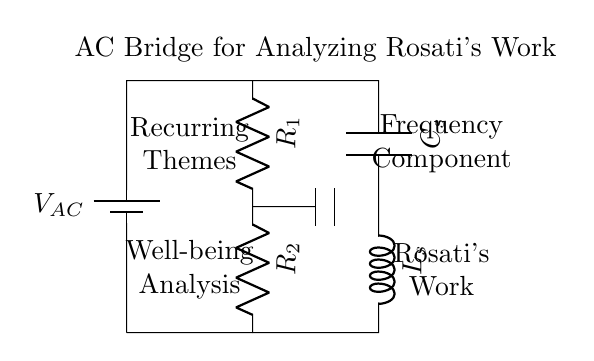What is the voltage source in this circuit? The voltage source is indicated by the battery symbol labeled with \( V_{AC} \) at the top left of the circuit diagram, suggesting it is an alternating current source.
Answer: V_{AC} How many resistors are present in the circuit? The diagram shows two resistors labeled \( R_1 \) and \( R_2 \). Both are connected in series in the left branch of the circuit.
Answer: 2 Which components are connected in parallel? The capacitor \( C_s \) and the inductor \( L_s \) are positioned in parallel within the right branch of the circuit, connecting at their respective terminals to the common nodes.
Answer: Capacitor and inductor What is the purpose of this AC bridge circuit? The AC bridge circuit is designed to analyze recurring themes in Rosati's work on well-being by measuring frequency components associated with the resonant characteristics of the network.
Answer: Analyze themes What happens to the voltage across the resistors when the circuit is balanced? When the AC bridge is balanced, the voltage across the resistors \( R_1 \) and \( R_2 \) will be equal, resulting in no potential difference across the measuring points, indicating balanced conditions.
Answer: Voltage equal How does the presence of capacitor and inductor influence the frequency analysis? The capacitor \( C_s \) and inductor \( L_s \) affect the impedance in the circuit, creating a frequency-dependent behavior that can be used to analyze resonant frequencies associated with recurring themes in Rosati's work.
Answer: Impedance variation 